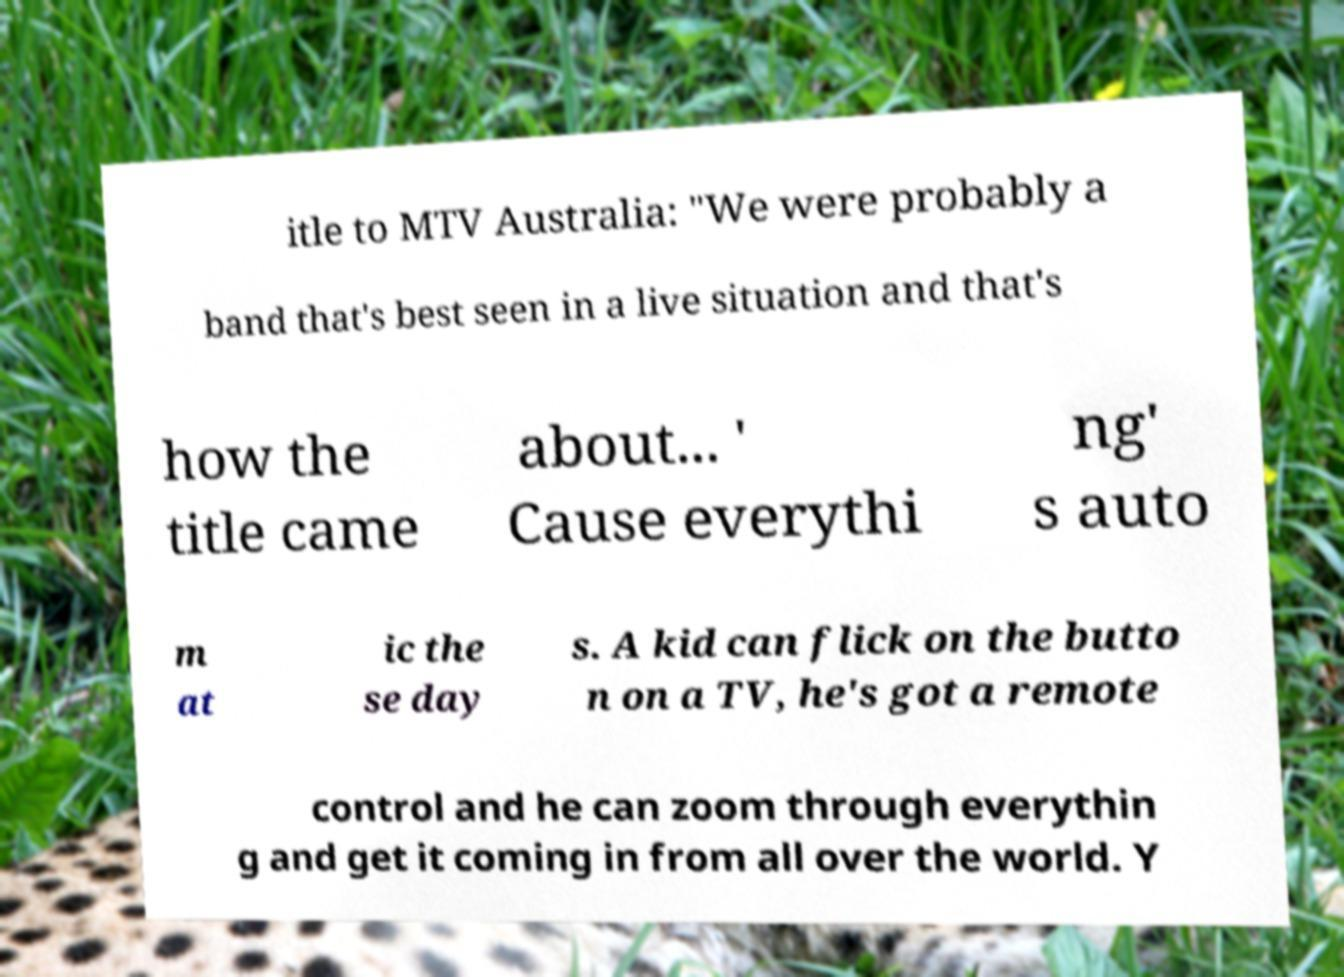For documentation purposes, I need the text within this image transcribed. Could you provide that? itle to MTV Australia: "We were probably a band that's best seen in a live situation and that's how the title came about... ' Cause everythi ng' s auto m at ic the se day s. A kid can flick on the butto n on a TV, he's got a remote control and he can zoom through everythin g and get it coming in from all over the world. Y 